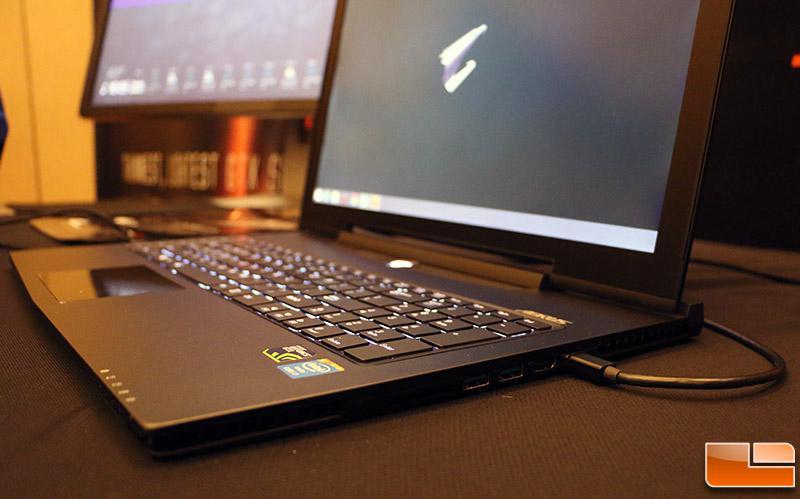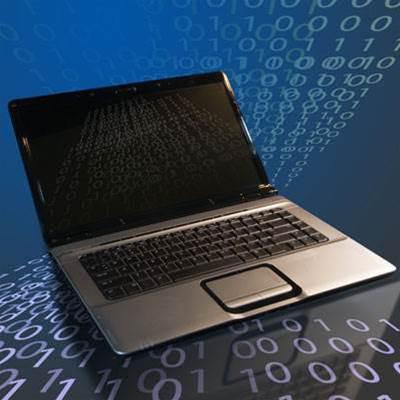The first image is the image on the left, the second image is the image on the right. For the images displayed, is the sentence "There are multiple squares shown on a laptop screen in one of the images." factually correct? Answer yes or no. No. The first image is the image on the left, the second image is the image on the right. Given the left and right images, does the statement "Each image shows one open laptop, and the lefthand laptop has a cord plugged into its right side." hold true? Answer yes or no. Yes. 